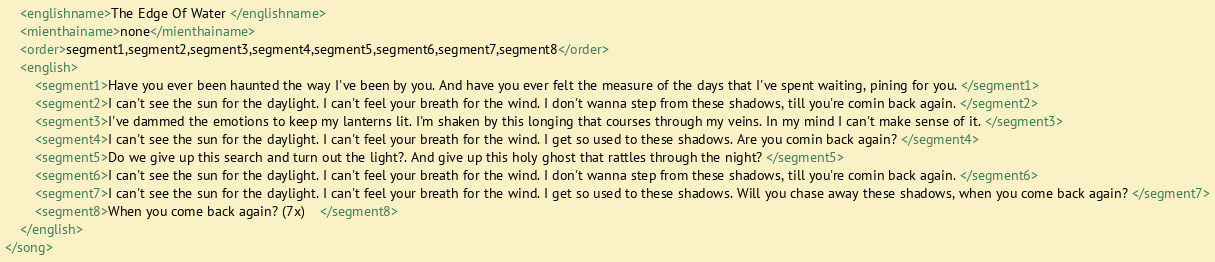Convert code to text. <code><loc_0><loc_0><loc_500><loc_500><_XML_>	<englishname>The Edge Of Water </englishname>
	<mienthainame>none</mienthainame>
	<order>segment1,segment2,segment3,segment4,segment5,segment6,segment7,segment8</order>
	<english>
		<segment1>Have you ever been haunted the way I've been by you. And have you ever felt the measure of the days that I've spent waiting, pining for you. </segment1>
		<segment2>I can't see the sun for the daylight. I can't feel your breath for the wind. I don't wanna step from these shadows, till you're comin back again. </segment2>
		<segment3>I've dammed the emotions to keep my lanterns lit. I'm shaken by this longing that courses through my veins. In my mind I can't make sense of it. </segment3>
		<segment4>I can't see the sun for the daylight. I can't feel your breath for the wind. I get so used to these shadows. Are you comin back again? </segment4>
		<segment5>Do we give up this search and turn out the light?. And give up this holy ghost that rattles through the night? </segment5>
		<segment6>I can't see the sun for the daylight. I can't feel your breath for the wind. I don't wanna step from these shadows, till you're comin back again. </segment6>
		<segment7>I can't see the sun for the daylight. I can't feel your breath for the wind. I get so used to these shadows. Will you chase away these shadows, when you come back again? </segment7>
		<segment8>When you come back again? (7x)    </segment8>
	</english>
</song>
</code> 